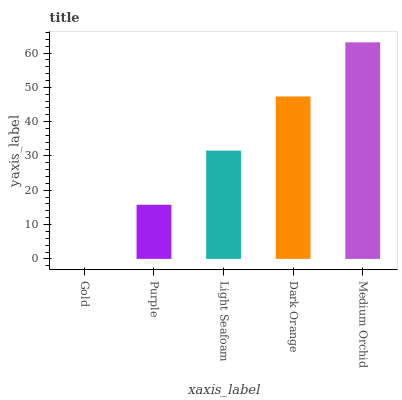Is Gold the minimum?
Answer yes or no. Yes. Is Medium Orchid the maximum?
Answer yes or no. Yes. Is Purple the minimum?
Answer yes or no. No. Is Purple the maximum?
Answer yes or no. No. Is Purple greater than Gold?
Answer yes or no. Yes. Is Gold less than Purple?
Answer yes or no. Yes. Is Gold greater than Purple?
Answer yes or no. No. Is Purple less than Gold?
Answer yes or no. No. Is Light Seafoam the high median?
Answer yes or no. Yes. Is Light Seafoam the low median?
Answer yes or no. Yes. Is Gold the high median?
Answer yes or no. No. Is Medium Orchid the low median?
Answer yes or no. No. 